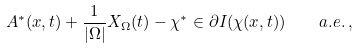Convert formula to latex. <formula><loc_0><loc_0><loc_500><loc_500>A ^ { * } ( x , t ) + \frac { 1 } { | \Omega | } X _ { \Omega } ( t ) - \chi ^ { * } \in \partial I ( \chi ( x , t ) ) \quad a . e . \, ,</formula> 